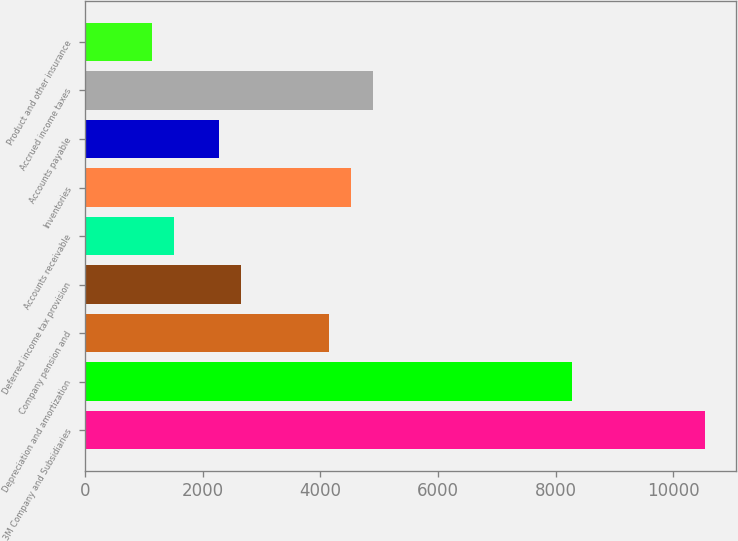<chart> <loc_0><loc_0><loc_500><loc_500><bar_chart><fcel>3M Company and Subsidiaries<fcel>Depreciation and amortization<fcel>Company pension and<fcel>Deferred income tax provision<fcel>Accounts receivable<fcel>Inventories<fcel>Accounts payable<fcel>Accrued income taxes<fcel>Product and other insurance<nl><fcel>10541<fcel>8285<fcel>4149<fcel>2645<fcel>1517<fcel>4525<fcel>2269<fcel>4901<fcel>1141<nl></chart> 